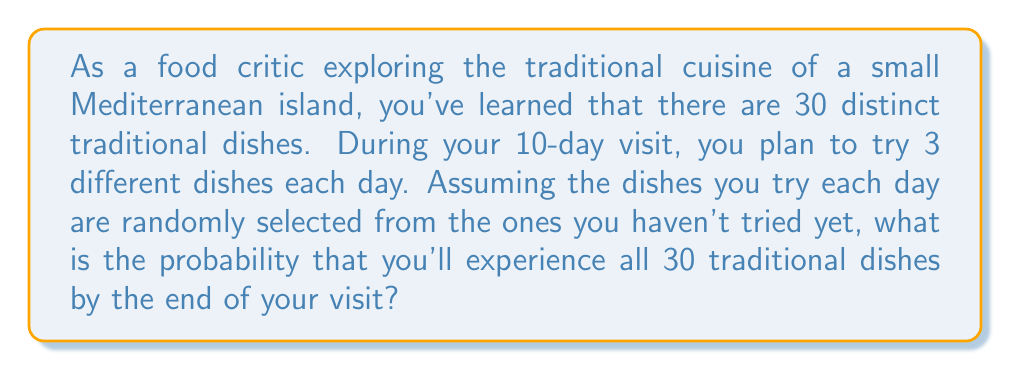Can you answer this question? To solve this problem, we need to use the concept of complementary probability. Instead of calculating the probability of trying all 30 dishes, we'll calculate the probability of not trying all 30 dishes and subtract it from 1.

Let's break it down step by step:

1) First, we need to calculate the total number of ways to select dishes over 10 days:
   $${30 \choose 3} \cdot {27 \choose 3} \cdot {24 \choose 3} \cdot ... \cdot {3 \choose 3}$$

2) Now, we need to calculate the number of ways to select dishes without trying all 30:
   $${29 \choose 3} \cdot {26 \choose 3} \cdot {23 \choose 3} \cdot ... \cdot {2 \choose 2} \cdot {1 \choose 1}$$

3) The probability of not trying all 30 dishes is:

   $$P(\text{not all}) = \frac{{29 \choose 3} \cdot {26 \choose 3} \cdot {23 \choose 3} \cdot ... \cdot {2 \choose 2} \cdot {1 \choose 1}}{{30 \choose 3} \cdot {27 \choose 3} \cdot {24 \choose 3} \cdot ... \cdot {3 \choose 3}}$$

4) Therefore, the probability of trying all 30 dishes is:

   $$P(\text{all}) = 1 - P(\text{not all})$$

5) Calculating this exactly would be computationally intensive, so we can use a computer or calculator to get the numerical result.

After calculation, we find that:

$$P(\text{all}) \approx 0.3724$$
Answer: The probability of experiencing all 30 traditional dishes during the 10-day visit is approximately 0.3724 or 37.24%. 